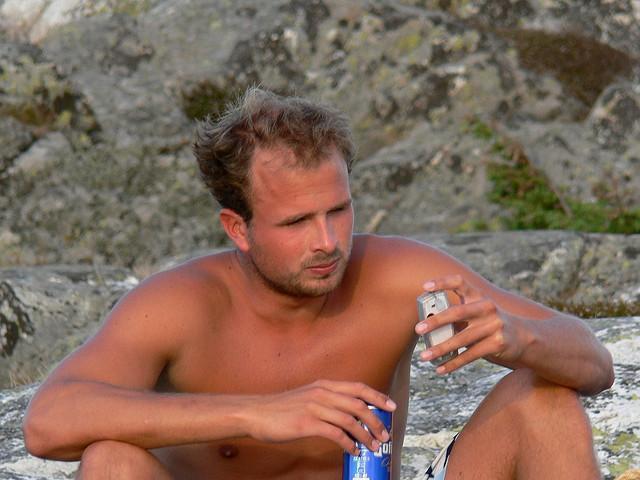What is the man holding?
Answer the question by selecting the correct answer among the 4 following choices.
Options: Baby, apple, can, kitten. Can. 